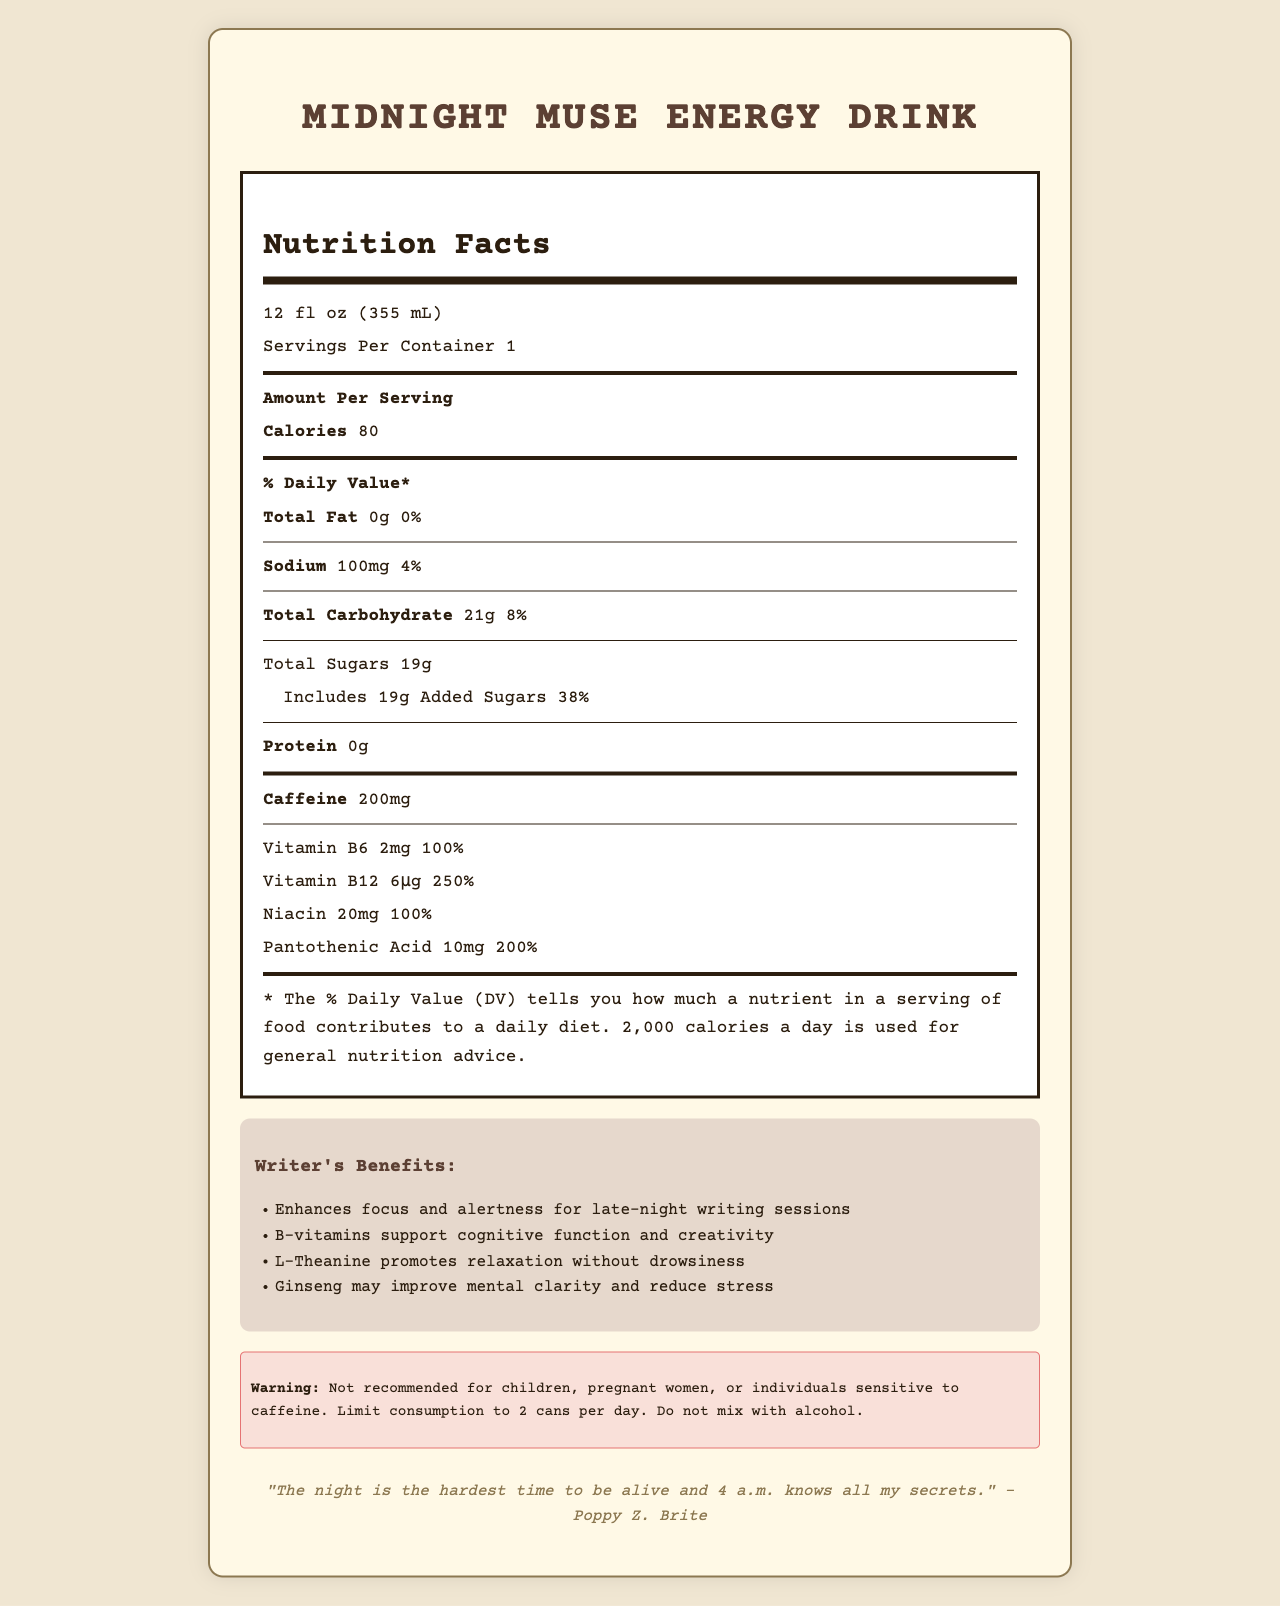what is the serving size? The serving size is clearly stated below the product name as "12 fl oz (355 mL)".
Answer: 12 fl oz (355 mL) how many calories are in one serving? The calories per serving are listed as 80, which is prominently displayed in the "Amount Per Serving" section.
Answer: 80 what is the daily value percentage for total carbohydrates? The daily value percentage for total carbohydrates is given as 8%, located next to the total carbohydrate amount.
Answer: 8% how much caffeine is in the drink? The amount of caffeine is listed explicitly as 200mg in the nutrition facts.
Answer: 200mg what are the four main writer’s benefits suggested for drinking this beverage? The document lists these benefits under the "Writer's Benefits" section as bullet points.
Answer: Enhances focus and alertness, B-vitamins support cognitive function and creativity, L-Theanine promotes relaxation without drowsiness, Ginseng may improve mental clarity and reduce stress of the following ingredients, which is not listed in the "other ingredients" section? A. Taurine B. Citric Acid C. High Fructose Corn Syrup D. L-Theanine "High Fructose Corn Syrup" is not listed as an ingredient, while the other options are.
Answer: C what % daily value of added sugars does the beverage provide? The % daily value for added sugars is stated as 38% under the total sugars section.
Answer: 38% which vitamin has the highest % daily value in this drink? A. Vitamin B6 B. Pantothenic Acid C. Vitamin B12 D. Niacin Vitamin B12 has the highest % daily value at 250%, as indicated in the vitamins and minerals section.
Answer: C is this beverage recommended for children and pregnant women? The usage warning specifies that it is not recommended for children and pregnant women.
Answer: No summarize the main features of Midnight Muse Energy Drink. The document provides detailed nutritional information, ingredients, vitamins, and suggested benefits, emphasizing its use for late-night writing sessions with explicit warnings and usage instructions.
Answer: Midnight Muse Energy Drink provides 80 calories per 12 fl oz serving with added sugars making up 38% of the daily value. Key ingredients include caffeine (200mg), B-vitamins, taurine, and ginseng, which are intended to enhance focus, alertness, and cognitive function. It should be used with caution and not be consumed by children or pregnant women. what is the color of the document header text for "Nutrition Facts"? The document's visual details, such as colors, are not described in the provided data, so this information cannot be determined.
Answer: Not enough information how many servings are there per container? The document states that there is one serving per container, which is noted right below the serving size.
Answer: 1 